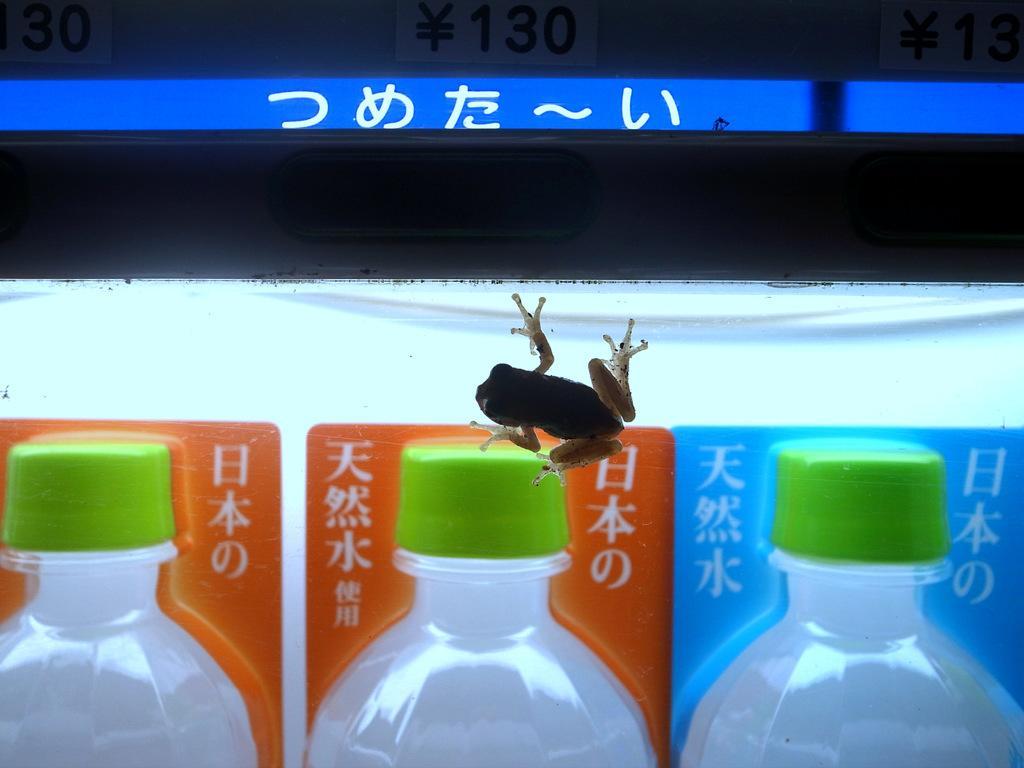Describe this image in one or two sentences. In this image i can see few bottles and a frog. 